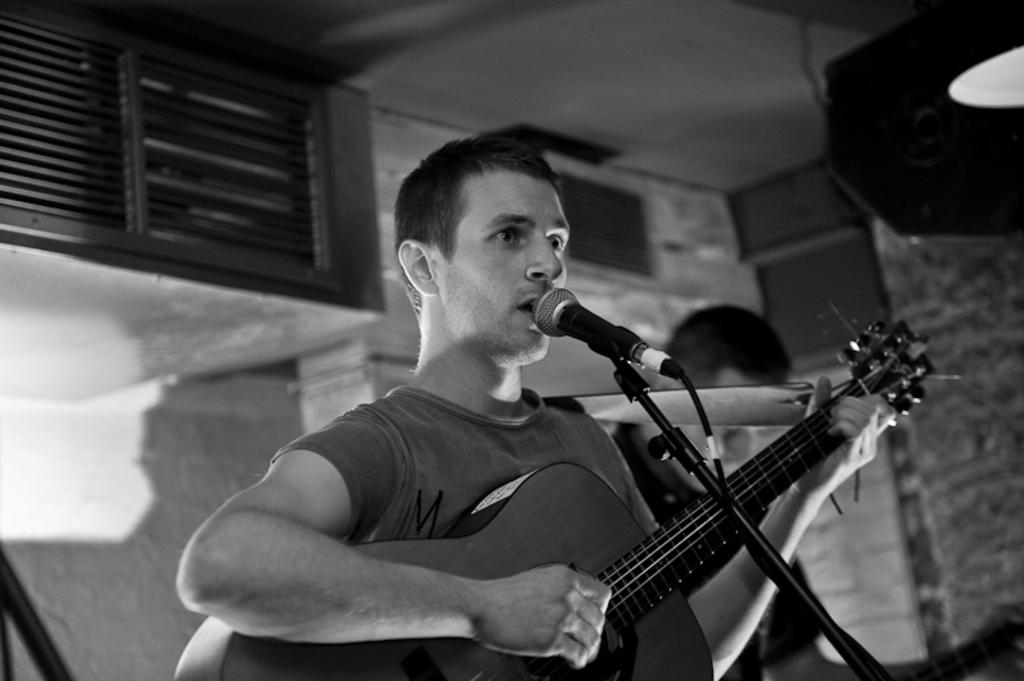What type of structure can be seen in the image? There is a wall in the image. Is there any opening in the wall? Yes, there is a window in the image. How many people are present in the image? There are two people in the image. What is one of the people holding? One of the people is holding a guitar. What object is in front of the person holding the guitar? There is a microphone in front of the person holding the guitar. What type of distribution system can be seen in the image? There is no distribution system present in the image. Are there any bushes visible in the image? There is no mention of bushes in the provided facts, so we cannot determine if they are present in the image. 